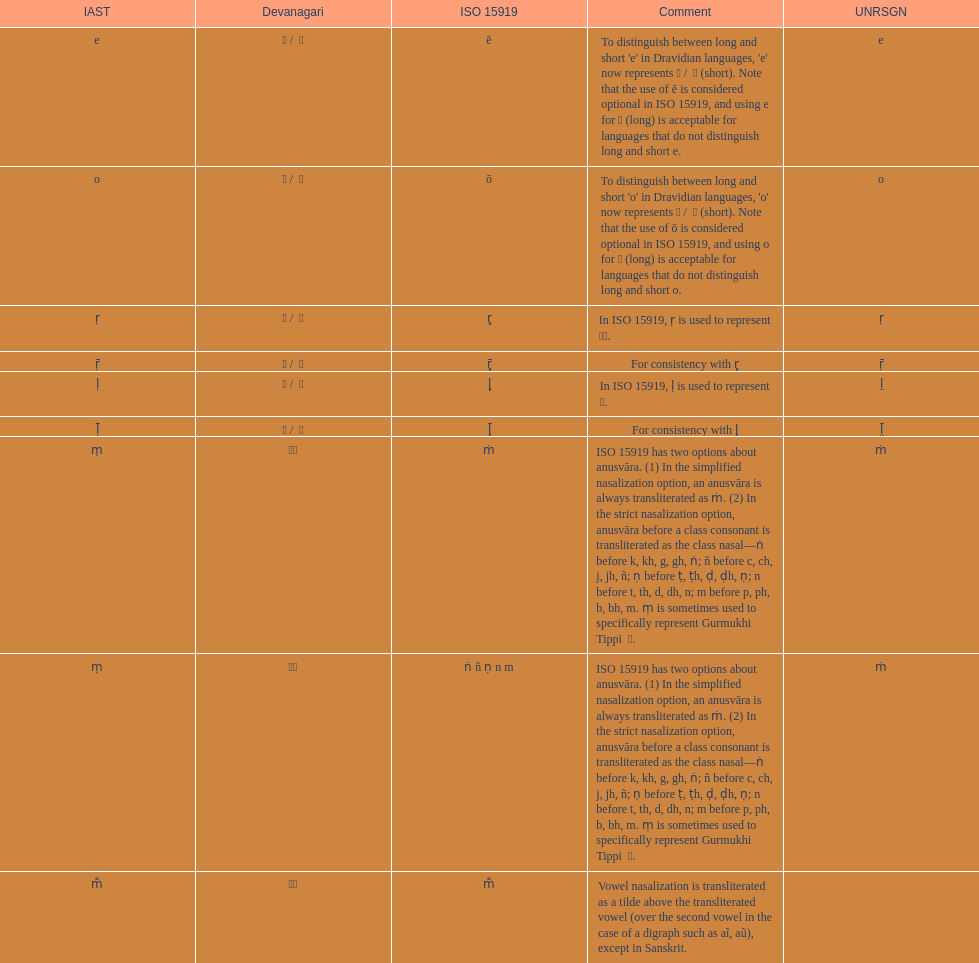What unrsgn is noted prior to the o? E. 